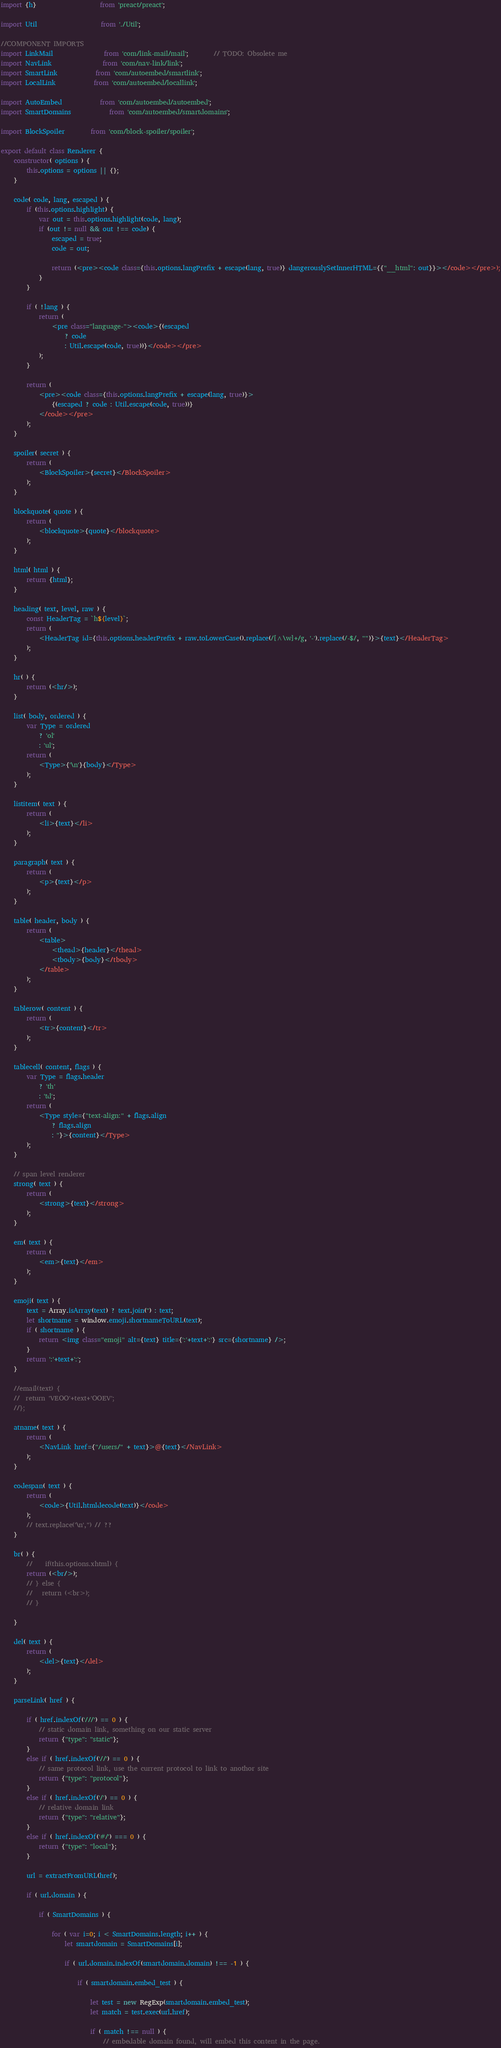<code> <loc_0><loc_0><loc_500><loc_500><_JavaScript_>import {h} 					from 'preact/preact';

import Util					from './Util';

//COMPONENT IMPORTS
import LinkMail				from 'com/link-mail/mail';		// TODO: Obsolete me
import NavLink 				from 'com/nav-link/link';
import SmartLink 			from 'com/autoembed/smartlink';
import LocalLink			from 'com/autoembed/locallink';

import AutoEmbed 			from 'com/autoembed/autoembed';
import SmartDomains			from 'com/autoembed/smartdomains';

import BlockSpoiler 		from 'com/block-spoiler/spoiler';

export default class Renderer {
	constructor( options ) {
		this.options = options || {};
	}

	code( code, lang, escaped ) {
		if (this.options.highlight) {
			var out = this.options.highlight(code, lang);
			if (out != null && out !== code) {
				escaped = true;
				code = out;

				return (<pre><code class={this.options.langPrefix + escape(lang, true)} dangerouslySetInnerHTML={{"__html": out}}></code></pre>);
			}
		}

		if ( !lang ) {
			return (
				<pre class="language-"><code>{(escaped
					? code
					: Util.escape(code, true))}</code></pre>
			);
		}

		return (
			<pre><code class={this.options.langPrefix + escape(lang, true)}>
				{(escaped ? code : Util.escape(code, true))}
			</code></pre>
		);
	}

	spoiler( secret ) {
		return (
			<BlockSpoiler>{secret}</BlockSpoiler>
		);
	}

	blockquote( quote ) {
		return (
			<blockquote>{quote}</blockquote>
		);
	}

	html( html ) {
		return {html};
	}

	heading( text, level, raw ) {
		const HeaderTag = `h${level}`;
		return (
			<HeaderTag id={this.options.headerPrefix + raw.toLowerCase().replace(/[^\w]+/g, '-').replace(/-$/, "")}>{text}</HeaderTag>
		);
	}

	hr( ) {
		return (<hr/>);
	}

	list( body, ordered ) {
		var Type = ordered
			? 'ol'
			: 'ul';
		return (
			<Type>{'\n'}{body}</Type>
		);
	}

	listitem( text ) {
		return (
			<li>{text}</li>
		);
	}

	paragraph( text ) {
		return (
			<p>{text}</p>
		);
	}

	table( header, body ) {
		return (
			<table>
				<thead>{header}</thead>
				<tbody>{body}</tbody>
			</table>
		);
	}

	tablerow( content ) {
		return (
			<tr>{content}</tr>
		);
	}

	tablecell( content, flags ) {
		var Type = flags.header
			? 'th'
			: 'td';
		return (
			<Type style={"text-align:" + flags.align
				? flags.align
				: ''}>{content}</Type>
		);
	}

	// span level renderer
	strong( text ) {
		return (
			<strong>{text}</strong>
		);
	}

	em( text ) {
		return (
			<em>{text}</em>
		);
	}

	emoji( text ) {
		text = Array.isArray(text) ? text.join('') : text;
		let shortname = window.emoji.shortnameToURL(text);
		if ( shortname ) {
			return <img class="emoji" alt={text} title={':'+text+':'} src={shortname} />;
		}
		return ':'+text+':';
	}

	//email(text) {
	//  return 'VEOO'+text+'OOEV';
	//};

	atname( text ) {
		return (
			<NavLink href={"/users/" + text}>@{text}</NavLink>
		);
	}

	codespan( text ) {
		return (
			<code>{Util.htmldecode(text)}</code>
		);
		// text.replace('\n','') // ??
	}

	br( ) {
		//    if(this.options.xhtml) {
		return (<br/>);
		// } else {
		//   return (<br>);
		// }

	}

	del( text ) {
		return (
			<del>{text}</del>
		);
	}

	parseLink( href ) {

		if ( href.indexOf('///') == 0 ) {
			// static domain link, something on our static server
			return {"type": "static"};
		}
		else if ( href.indexOf('//') == 0 ) {
			// same protocol link, use the current protocol to link to anothor site
			return {"type": "protocol"};
		}
		else if ( href.indexOf('/') == 0 ) {
			// relative domain link
			return {"type": "relative"};
		}
		else if ( href.indexOf('#/') === 0 ) {
			return {"type": "local"};
		}

		url = extractFromURL(href);

		if ( url.domain ) {

			if ( SmartDomains ) {

				for ( var i=0; i < SmartDomains.length; i++ ) {
					let smartdomain = SmartDomains[i];

					if ( url.domain.indexOf(smartdomain.domain) !== -1 ) {

						if ( smartdomain.embed_test ) {

							let test = new RegExp(smartdomain.embed_test);
							let match = test.exec(url.href);

							if ( match !== null ) {
								// embedable domain found, will embed this content in the page.</code> 